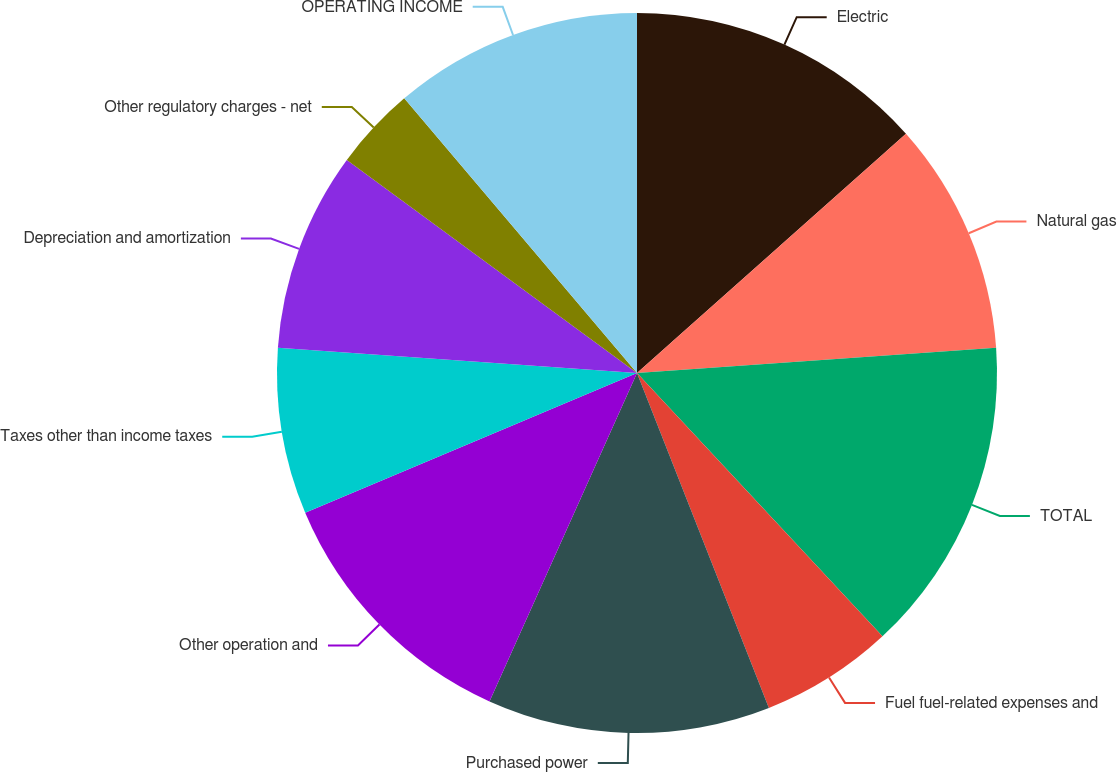<chart> <loc_0><loc_0><loc_500><loc_500><pie_chart><fcel>Electric<fcel>Natural gas<fcel>TOTAL<fcel>Fuel fuel-related expenses and<fcel>Purchased power<fcel>Other operation and<fcel>Taxes other than income taxes<fcel>Depreciation and amortization<fcel>Other regulatory charges - net<fcel>OPERATING INCOME<nl><fcel>13.43%<fcel>10.45%<fcel>14.18%<fcel>5.97%<fcel>12.69%<fcel>11.94%<fcel>7.46%<fcel>8.96%<fcel>3.73%<fcel>11.19%<nl></chart> 